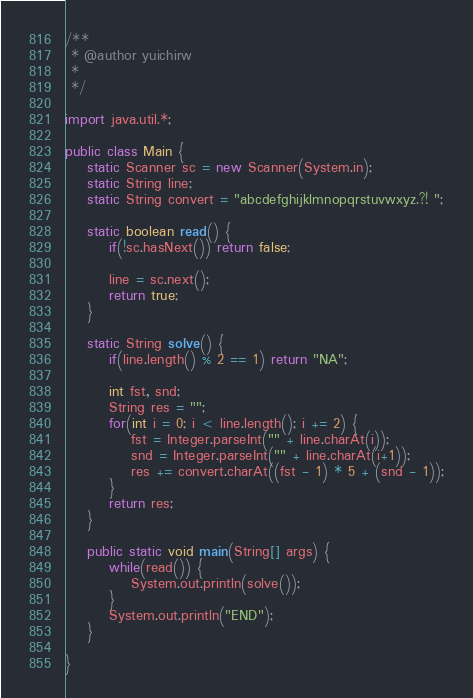<code> <loc_0><loc_0><loc_500><loc_500><_Java_>/**
 * @author yuichirw
 *
 */

import java.util.*;

public class Main {
	static Scanner sc = new Scanner(System.in);
	static String line;
	static String convert = "abcdefghijklmnopqrstuvwxyz.?! ";

	static boolean read() {
		if(!sc.hasNext()) return false;
		
		line = sc.next();
		return true;
	}
	
	static String solve() {
		if(line.length() % 2 == 1) return "NA";
		
		int fst, snd;
		String res = "";
		for(int i = 0; i < line.length(); i += 2) {
			fst = Integer.parseInt("" + line.charAt(i));
			snd = Integer.parseInt("" + line.charAt(i+1));
			res += convert.charAt((fst - 1) * 5 + (snd - 1));
		}
		return res;
	}
	
	public static void main(String[] args) {
		while(read()) {
			System.out.println(solve());
		}
		System.out.println("END");
	}

}</code> 